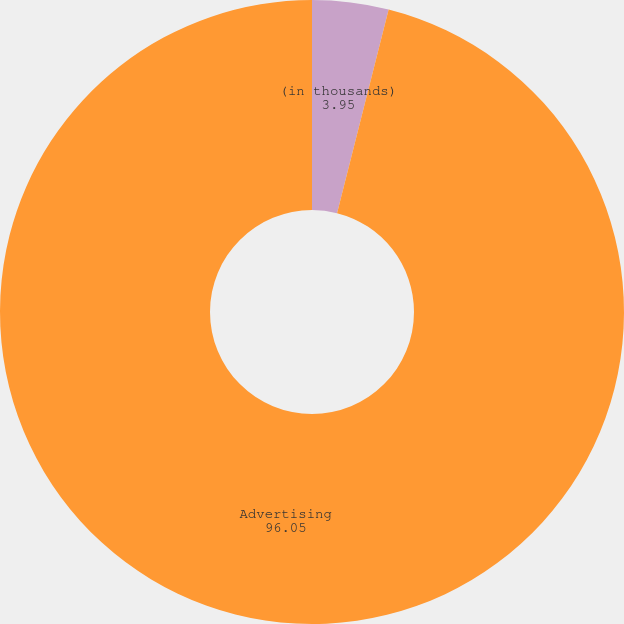Convert chart to OTSL. <chart><loc_0><loc_0><loc_500><loc_500><pie_chart><fcel>(in thousands)<fcel>Advertising<nl><fcel>3.95%<fcel>96.05%<nl></chart> 